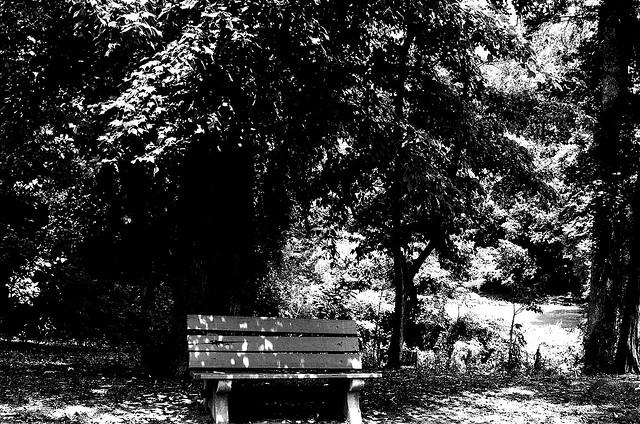The main subject of this photo is of what object?
Quick response, please. Bench. Is this downtown?
Quick response, please. No. What might this object be used for?
Answer briefly. Sitting. Is this an old photo?
Write a very short answer. Yes. 